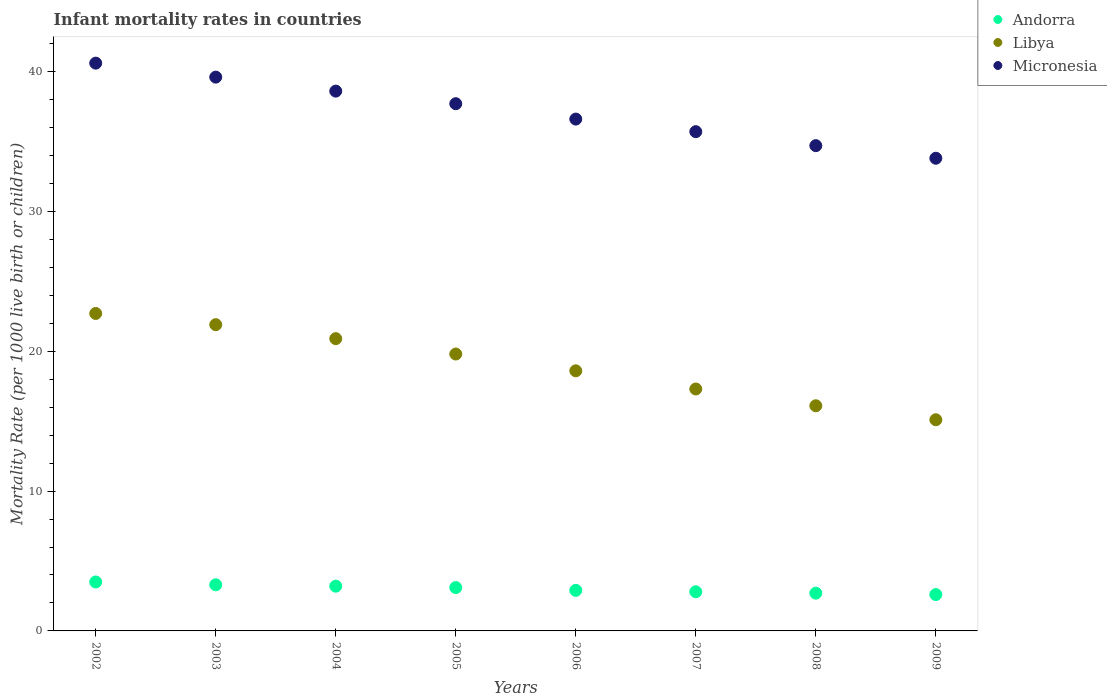How many different coloured dotlines are there?
Provide a succinct answer. 3. Is the number of dotlines equal to the number of legend labels?
Your answer should be compact. Yes. Across all years, what is the maximum infant mortality rate in Libya?
Provide a succinct answer. 22.7. Across all years, what is the minimum infant mortality rate in Andorra?
Make the answer very short. 2.6. In which year was the infant mortality rate in Libya minimum?
Give a very brief answer. 2009. What is the total infant mortality rate in Micronesia in the graph?
Your response must be concise. 297.3. What is the difference between the infant mortality rate in Andorra in 2002 and that in 2008?
Ensure brevity in your answer.  0.8. What is the difference between the infant mortality rate in Micronesia in 2005 and the infant mortality rate in Andorra in 2007?
Your response must be concise. 34.9. What is the average infant mortality rate in Andorra per year?
Your response must be concise. 3.01. In the year 2009, what is the difference between the infant mortality rate in Andorra and infant mortality rate in Micronesia?
Your response must be concise. -31.2. In how many years, is the infant mortality rate in Andorra greater than 24?
Provide a short and direct response. 0. What is the ratio of the infant mortality rate in Micronesia in 2005 to that in 2006?
Provide a short and direct response. 1.03. Is the infant mortality rate in Micronesia in 2003 less than that in 2008?
Your answer should be compact. No. Is the difference between the infant mortality rate in Andorra in 2004 and 2006 greater than the difference between the infant mortality rate in Micronesia in 2004 and 2006?
Keep it short and to the point. No. What is the difference between the highest and the second highest infant mortality rate in Andorra?
Your response must be concise. 0.2. What is the difference between the highest and the lowest infant mortality rate in Libya?
Give a very brief answer. 7.6. Is the sum of the infant mortality rate in Micronesia in 2002 and 2007 greater than the maximum infant mortality rate in Andorra across all years?
Provide a succinct answer. Yes. Is the infant mortality rate in Andorra strictly greater than the infant mortality rate in Libya over the years?
Offer a very short reply. No. Is the infant mortality rate in Libya strictly less than the infant mortality rate in Micronesia over the years?
Give a very brief answer. Yes. What is the difference between two consecutive major ticks on the Y-axis?
Ensure brevity in your answer.  10. Does the graph contain any zero values?
Ensure brevity in your answer.  No. Does the graph contain grids?
Offer a very short reply. No. How are the legend labels stacked?
Keep it short and to the point. Vertical. What is the title of the graph?
Provide a short and direct response. Infant mortality rates in countries. What is the label or title of the Y-axis?
Your answer should be very brief. Mortality Rate (per 1000 live birth or children). What is the Mortality Rate (per 1000 live birth or children) in Andorra in 2002?
Provide a short and direct response. 3.5. What is the Mortality Rate (per 1000 live birth or children) of Libya in 2002?
Your answer should be compact. 22.7. What is the Mortality Rate (per 1000 live birth or children) of Micronesia in 2002?
Keep it short and to the point. 40.6. What is the Mortality Rate (per 1000 live birth or children) in Andorra in 2003?
Provide a succinct answer. 3.3. What is the Mortality Rate (per 1000 live birth or children) in Libya in 2003?
Keep it short and to the point. 21.9. What is the Mortality Rate (per 1000 live birth or children) in Micronesia in 2003?
Give a very brief answer. 39.6. What is the Mortality Rate (per 1000 live birth or children) in Andorra in 2004?
Offer a terse response. 3.2. What is the Mortality Rate (per 1000 live birth or children) in Libya in 2004?
Offer a terse response. 20.9. What is the Mortality Rate (per 1000 live birth or children) of Micronesia in 2004?
Ensure brevity in your answer.  38.6. What is the Mortality Rate (per 1000 live birth or children) in Libya in 2005?
Provide a short and direct response. 19.8. What is the Mortality Rate (per 1000 live birth or children) of Micronesia in 2005?
Provide a short and direct response. 37.7. What is the Mortality Rate (per 1000 live birth or children) in Libya in 2006?
Your response must be concise. 18.6. What is the Mortality Rate (per 1000 live birth or children) of Micronesia in 2006?
Your response must be concise. 36.6. What is the Mortality Rate (per 1000 live birth or children) of Micronesia in 2007?
Provide a short and direct response. 35.7. What is the Mortality Rate (per 1000 live birth or children) in Andorra in 2008?
Provide a succinct answer. 2.7. What is the Mortality Rate (per 1000 live birth or children) of Libya in 2008?
Provide a short and direct response. 16.1. What is the Mortality Rate (per 1000 live birth or children) of Micronesia in 2008?
Your answer should be very brief. 34.7. What is the Mortality Rate (per 1000 live birth or children) in Andorra in 2009?
Provide a succinct answer. 2.6. What is the Mortality Rate (per 1000 live birth or children) in Micronesia in 2009?
Your response must be concise. 33.8. Across all years, what is the maximum Mortality Rate (per 1000 live birth or children) in Andorra?
Ensure brevity in your answer.  3.5. Across all years, what is the maximum Mortality Rate (per 1000 live birth or children) in Libya?
Make the answer very short. 22.7. Across all years, what is the maximum Mortality Rate (per 1000 live birth or children) in Micronesia?
Offer a very short reply. 40.6. Across all years, what is the minimum Mortality Rate (per 1000 live birth or children) in Andorra?
Provide a succinct answer. 2.6. Across all years, what is the minimum Mortality Rate (per 1000 live birth or children) in Micronesia?
Offer a terse response. 33.8. What is the total Mortality Rate (per 1000 live birth or children) of Andorra in the graph?
Offer a terse response. 24.1. What is the total Mortality Rate (per 1000 live birth or children) of Libya in the graph?
Make the answer very short. 152.4. What is the total Mortality Rate (per 1000 live birth or children) in Micronesia in the graph?
Keep it short and to the point. 297.3. What is the difference between the Mortality Rate (per 1000 live birth or children) of Andorra in 2002 and that in 2003?
Make the answer very short. 0.2. What is the difference between the Mortality Rate (per 1000 live birth or children) of Libya in 2002 and that in 2004?
Ensure brevity in your answer.  1.8. What is the difference between the Mortality Rate (per 1000 live birth or children) in Micronesia in 2002 and that in 2004?
Your answer should be compact. 2. What is the difference between the Mortality Rate (per 1000 live birth or children) in Andorra in 2002 and that in 2005?
Offer a terse response. 0.4. What is the difference between the Mortality Rate (per 1000 live birth or children) of Micronesia in 2002 and that in 2005?
Your answer should be very brief. 2.9. What is the difference between the Mortality Rate (per 1000 live birth or children) in Andorra in 2002 and that in 2006?
Make the answer very short. 0.6. What is the difference between the Mortality Rate (per 1000 live birth or children) in Libya in 2002 and that in 2006?
Your answer should be compact. 4.1. What is the difference between the Mortality Rate (per 1000 live birth or children) of Micronesia in 2002 and that in 2006?
Your answer should be compact. 4. What is the difference between the Mortality Rate (per 1000 live birth or children) of Libya in 2002 and that in 2007?
Your answer should be compact. 5.4. What is the difference between the Mortality Rate (per 1000 live birth or children) in Andorra in 2002 and that in 2008?
Your answer should be very brief. 0.8. What is the difference between the Mortality Rate (per 1000 live birth or children) in Andorra in 2002 and that in 2009?
Provide a succinct answer. 0.9. What is the difference between the Mortality Rate (per 1000 live birth or children) in Micronesia in 2002 and that in 2009?
Make the answer very short. 6.8. What is the difference between the Mortality Rate (per 1000 live birth or children) in Andorra in 2003 and that in 2004?
Offer a terse response. 0.1. What is the difference between the Mortality Rate (per 1000 live birth or children) in Andorra in 2003 and that in 2005?
Your answer should be very brief. 0.2. What is the difference between the Mortality Rate (per 1000 live birth or children) in Libya in 2003 and that in 2005?
Ensure brevity in your answer.  2.1. What is the difference between the Mortality Rate (per 1000 live birth or children) in Andorra in 2003 and that in 2006?
Give a very brief answer. 0.4. What is the difference between the Mortality Rate (per 1000 live birth or children) of Libya in 2003 and that in 2006?
Provide a short and direct response. 3.3. What is the difference between the Mortality Rate (per 1000 live birth or children) of Libya in 2003 and that in 2007?
Your answer should be very brief. 4.6. What is the difference between the Mortality Rate (per 1000 live birth or children) of Andorra in 2003 and that in 2008?
Offer a very short reply. 0.6. What is the difference between the Mortality Rate (per 1000 live birth or children) of Andorra in 2003 and that in 2009?
Keep it short and to the point. 0.7. What is the difference between the Mortality Rate (per 1000 live birth or children) of Andorra in 2004 and that in 2005?
Your answer should be very brief. 0.1. What is the difference between the Mortality Rate (per 1000 live birth or children) in Libya in 2004 and that in 2005?
Provide a succinct answer. 1.1. What is the difference between the Mortality Rate (per 1000 live birth or children) of Micronesia in 2004 and that in 2006?
Offer a very short reply. 2. What is the difference between the Mortality Rate (per 1000 live birth or children) of Andorra in 2004 and that in 2007?
Offer a terse response. 0.4. What is the difference between the Mortality Rate (per 1000 live birth or children) of Libya in 2004 and that in 2007?
Provide a succinct answer. 3.6. What is the difference between the Mortality Rate (per 1000 live birth or children) in Libya in 2004 and that in 2008?
Give a very brief answer. 4.8. What is the difference between the Mortality Rate (per 1000 live birth or children) in Andorra in 2004 and that in 2009?
Your answer should be compact. 0.6. What is the difference between the Mortality Rate (per 1000 live birth or children) of Libya in 2004 and that in 2009?
Make the answer very short. 5.8. What is the difference between the Mortality Rate (per 1000 live birth or children) in Libya in 2005 and that in 2006?
Your answer should be very brief. 1.2. What is the difference between the Mortality Rate (per 1000 live birth or children) of Micronesia in 2005 and that in 2006?
Your answer should be very brief. 1.1. What is the difference between the Mortality Rate (per 1000 live birth or children) in Andorra in 2005 and that in 2007?
Provide a short and direct response. 0.3. What is the difference between the Mortality Rate (per 1000 live birth or children) in Micronesia in 2005 and that in 2007?
Your answer should be compact. 2. What is the difference between the Mortality Rate (per 1000 live birth or children) of Andorra in 2005 and that in 2008?
Give a very brief answer. 0.4. What is the difference between the Mortality Rate (per 1000 live birth or children) in Micronesia in 2005 and that in 2008?
Offer a very short reply. 3. What is the difference between the Mortality Rate (per 1000 live birth or children) of Andorra in 2005 and that in 2009?
Provide a succinct answer. 0.5. What is the difference between the Mortality Rate (per 1000 live birth or children) in Libya in 2005 and that in 2009?
Offer a terse response. 4.7. What is the difference between the Mortality Rate (per 1000 live birth or children) in Andorra in 2006 and that in 2007?
Your answer should be compact. 0.1. What is the difference between the Mortality Rate (per 1000 live birth or children) of Andorra in 2006 and that in 2008?
Provide a short and direct response. 0.2. What is the difference between the Mortality Rate (per 1000 live birth or children) in Andorra in 2006 and that in 2009?
Your response must be concise. 0.3. What is the difference between the Mortality Rate (per 1000 live birth or children) in Micronesia in 2006 and that in 2009?
Your answer should be compact. 2.8. What is the difference between the Mortality Rate (per 1000 live birth or children) of Libya in 2007 and that in 2009?
Your answer should be compact. 2.2. What is the difference between the Mortality Rate (per 1000 live birth or children) of Micronesia in 2007 and that in 2009?
Make the answer very short. 1.9. What is the difference between the Mortality Rate (per 1000 live birth or children) in Andorra in 2008 and that in 2009?
Your answer should be compact. 0.1. What is the difference between the Mortality Rate (per 1000 live birth or children) in Libya in 2008 and that in 2009?
Your answer should be compact. 1. What is the difference between the Mortality Rate (per 1000 live birth or children) of Andorra in 2002 and the Mortality Rate (per 1000 live birth or children) of Libya in 2003?
Provide a succinct answer. -18.4. What is the difference between the Mortality Rate (per 1000 live birth or children) of Andorra in 2002 and the Mortality Rate (per 1000 live birth or children) of Micronesia in 2003?
Offer a terse response. -36.1. What is the difference between the Mortality Rate (per 1000 live birth or children) in Libya in 2002 and the Mortality Rate (per 1000 live birth or children) in Micronesia in 2003?
Provide a short and direct response. -16.9. What is the difference between the Mortality Rate (per 1000 live birth or children) in Andorra in 2002 and the Mortality Rate (per 1000 live birth or children) in Libya in 2004?
Offer a very short reply. -17.4. What is the difference between the Mortality Rate (per 1000 live birth or children) in Andorra in 2002 and the Mortality Rate (per 1000 live birth or children) in Micronesia in 2004?
Provide a short and direct response. -35.1. What is the difference between the Mortality Rate (per 1000 live birth or children) in Libya in 2002 and the Mortality Rate (per 1000 live birth or children) in Micronesia in 2004?
Make the answer very short. -15.9. What is the difference between the Mortality Rate (per 1000 live birth or children) in Andorra in 2002 and the Mortality Rate (per 1000 live birth or children) in Libya in 2005?
Your response must be concise. -16.3. What is the difference between the Mortality Rate (per 1000 live birth or children) in Andorra in 2002 and the Mortality Rate (per 1000 live birth or children) in Micronesia in 2005?
Make the answer very short. -34.2. What is the difference between the Mortality Rate (per 1000 live birth or children) in Andorra in 2002 and the Mortality Rate (per 1000 live birth or children) in Libya in 2006?
Your response must be concise. -15.1. What is the difference between the Mortality Rate (per 1000 live birth or children) in Andorra in 2002 and the Mortality Rate (per 1000 live birth or children) in Micronesia in 2006?
Offer a terse response. -33.1. What is the difference between the Mortality Rate (per 1000 live birth or children) of Andorra in 2002 and the Mortality Rate (per 1000 live birth or children) of Libya in 2007?
Provide a succinct answer. -13.8. What is the difference between the Mortality Rate (per 1000 live birth or children) in Andorra in 2002 and the Mortality Rate (per 1000 live birth or children) in Micronesia in 2007?
Ensure brevity in your answer.  -32.2. What is the difference between the Mortality Rate (per 1000 live birth or children) of Andorra in 2002 and the Mortality Rate (per 1000 live birth or children) of Micronesia in 2008?
Offer a terse response. -31.2. What is the difference between the Mortality Rate (per 1000 live birth or children) in Libya in 2002 and the Mortality Rate (per 1000 live birth or children) in Micronesia in 2008?
Your response must be concise. -12. What is the difference between the Mortality Rate (per 1000 live birth or children) of Andorra in 2002 and the Mortality Rate (per 1000 live birth or children) of Libya in 2009?
Give a very brief answer. -11.6. What is the difference between the Mortality Rate (per 1000 live birth or children) in Andorra in 2002 and the Mortality Rate (per 1000 live birth or children) in Micronesia in 2009?
Offer a very short reply. -30.3. What is the difference between the Mortality Rate (per 1000 live birth or children) in Libya in 2002 and the Mortality Rate (per 1000 live birth or children) in Micronesia in 2009?
Provide a short and direct response. -11.1. What is the difference between the Mortality Rate (per 1000 live birth or children) in Andorra in 2003 and the Mortality Rate (per 1000 live birth or children) in Libya in 2004?
Provide a short and direct response. -17.6. What is the difference between the Mortality Rate (per 1000 live birth or children) of Andorra in 2003 and the Mortality Rate (per 1000 live birth or children) of Micronesia in 2004?
Provide a succinct answer. -35.3. What is the difference between the Mortality Rate (per 1000 live birth or children) of Libya in 2003 and the Mortality Rate (per 1000 live birth or children) of Micronesia in 2004?
Give a very brief answer. -16.7. What is the difference between the Mortality Rate (per 1000 live birth or children) of Andorra in 2003 and the Mortality Rate (per 1000 live birth or children) of Libya in 2005?
Your answer should be very brief. -16.5. What is the difference between the Mortality Rate (per 1000 live birth or children) in Andorra in 2003 and the Mortality Rate (per 1000 live birth or children) in Micronesia in 2005?
Keep it short and to the point. -34.4. What is the difference between the Mortality Rate (per 1000 live birth or children) of Libya in 2003 and the Mortality Rate (per 1000 live birth or children) of Micronesia in 2005?
Your answer should be compact. -15.8. What is the difference between the Mortality Rate (per 1000 live birth or children) of Andorra in 2003 and the Mortality Rate (per 1000 live birth or children) of Libya in 2006?
Give a very brief answer. -15.3. What is the difference between the Mortality Rate (per 1000 live birth or children) of Andorra in 2003 and the Mortality Rate (per 1000 live birth or children) of Micronesia in 2006?
Your response must be concise. -33.3. What is the difference between the Mortality Rate (per 1000 live birth or children) in Libya in 2003 and the Mortality Rate (per 1000 live birth or children) in Micronesia in 2006?
Provide a short and direct response. -14.7. What is the difference between the Mortality Rate (per 1000 live birth or children) of Andorra in 2003 and the Mortality Rate (per 1000 live birth or children) of Micronesia in 2007?
Give a very brief answer. -32.4. What is the difference between the Mortality Rate (per 1000 live birth or children) of Andorra in 2003 and the Mortality Rate (per 1000 live birth or children) of Libya in 2008?
Your response must be concise. -12.8. What is the difference between the Mortality Rate (per 1000 live birth or children) of Andorra in 2003 and the Mortality Rate (per 1000 live birth or children) of Micronesia in 2008?
Keep it short and to the point. -31.4. What is the difference between the Mortality Rate (per 1000 live birth or children) in Andorra in 2003 and the Mortality Rate (per 1000 live birth or children) in Libya in 2009?
Your answer should be compact. -11.8. What is the difference between the Mortality Rate (per 1000 live birth or children) of Andorra in 2003 and the Mortality Rate (per 1000 live birth or children) of Micronesia in 2009?
Offer a terse response. -30.5. What is the difference between the Mortality Rate (per 1000 live birth or children) in Andorra in 2004 and the Mortality Rate (per 1000 live birth or children) in Libya in 2005?
Give a very brief answer. -16.6. What is the difference between the Mortality Rate (per 1000 live birth or children) of Andorra in 2004 and the Mortality Rate (per 1000 live birth or children) of Micronesia in 2005?
Your answer should be very brief. -34.5. What is the difference between the Mortality Rate (per 1000 live birth or children) in Libya in 2004 and the Mortality Rate (per 1000 live birth or children) in Micronesia in 2005?
Make the answer very short. -16.8. What is the difference between the Mortality Rate (per 1000 live birth or children) of Andorra in 2004 and the Mortality Rate (per 1000 live birth or children) of Libya in 2006?
Provide a short and direct response. -15.4. What is the difference between the Mortality Rate (per 1000 live birth or children) of Andorra in 2004 and the Mortality Rate (per 1000 live birth or children) of Micronesia in 2006?
Ensure brevity in your answer.  -33.4. What is the difference between the Mortality Rate (per 1000 live birth or children) of Libya in 2004 and the Mortality Rate (per 1000 live birth or children) of Micronesia in 2006?
Provide a succinct answer. -15.7. What is the difference between the Mortality Rate (per 1000 live birth or children) in Andorra in 2004 and the Mortality Rate (per 1000 live birth or children) in Libya in 2007?
Your response must be concise. -14.1. What is the difference between the Mortality Rate (per 1000 live birth or children) in Andorra in 2004 and the Mortality Rate (per 1000 live birth or children) in Micronesia in 2007?
Provide a succinct answer. -32.5. What is the difference between the Mortality Rate (per 1000 live birth or children) in Libya in 2004 and the Mortality Rate (per 1000 live birth or children) in Micronesia in 2007?
Your response must be concise. -14.8. What is the difference between the Mortality Rate (per 1000 live birth or children) of Andorra in 2004 and the Mortality Rate (per 1000 live birth or children) of Micronesia in 2008?
Keep it short and to the point. -31.5. What is the difference between the Mortality Rate (per 1000 live birth or children) of Andorra in 2004 and the Mortality Rate (per 1000 live birth or children) of Micronesia in 2009?
Your answer should be very brief. -30.6. What is the difference between the Mortality Rate (per 1000 live birth or children) in Andorra in 2005 and the Mortality Rate (per 1000 live birth or children) in Libya in 2006?
Your answer should be very brief. -15.5. What is the difference between the Mortality Rate (per 1000 live birth or children) of Andorra in 2005 and the Mortality Rate (per 1000 live birth or children) of Micronesia in 2006?
Make the answer very short. -33.5. What is the difference between the Mortality Rate (per 1000 live birth or children) of Libya in 2005 and the Mortality Rate (per 1000 live birth or children) of Micronesia in 2006?
Offer a very short reply. -16.8. What is the difference between the Mortality Rate (per 1000 live birth or children) of Andorra in 2005 and the Mortality Rate (per 1000 live birth or children) of Micronesia in 2007?
Provide a short and direct response. -32.6. What is the difference between the Mortality Rate (per 1000 live birth or children) in Libya in 2005 and the Mortality Rate (per 1000 live birth or children) in Micronesia in 2007?
Offer a terse response. -15.9. What is the difference between the Mortality Rate (per 1000 live birth or children) of Andorra in 2005 and the Mortality Rate (per 1000 live birth or children) of Micronesia in 2008?
Give a very brief answer. -31.6. What is the difference between the Mortality Rate (per 1000 live birth or children) in Libya in 2005 and the Mortality Rate (per 1000 live birth or children) in Micronesia in 2008?
Make the answer very short. -14.9. What is the difference between the Mortality Rate (per 1000 live birth or children) in Andorra in 2005 and the Mortality Rate (per 1000 live birth or children) in Libya in 2009?
Provide a succinct answer. -12. What is the difference between the Mortality Rate (per 1000 live birth or children) in Andorra in 2005 and the Mortality Rate (per 1000 live birth or children) in Micronesia in 2009?
Provide a succinct answer. -30.7. What is the difference between the Mortality Rate (per 1000 live birth or children) in Andorra in 2006 and the Mortality Rate (per 1000 live birth or children) in Libya in 2007?
Provide a short and direct response. -14.4. What is the difference between the Mortality Rate (per 1000 live birth or children) in Andorra in 2006 and the Mortality Rate (per 1000 live birth or children) in Micronesia in 2007?
Your answer should be compact. -32.8. What is the difference between the Mortality Rate (per 1000 live birth or children) of Libya in 2006 and the Mortality Rate (per 1000 live birth or children) of Micronesia in 2007?
Make the answer very short. -17.1. What is the difference between the Mortality Rate (per 1000 live birth or children) of Andorra in 2006 and the Mortality Rate (per 1000 live birth or children) of Micronesia in 2008?
Your answer should be compact. -31.8. What is the difference between the Mortality Rate (per 1000 live birth or children) of Libya in 2006 and the Mortality Rate (per 1000 live birth or children) of Micronesia in 2008?
Keep it short and to the point. -16.1. What is the difference between the Mortality Rate (per 1000 live birth or children) in Andorra in 2006 and the Mortality Rate (per 1000 live birth or children) in Micronesia in 2009?
Offer a terse response. -30.9. What is the difference between the Mortality Rate (per 1000 live birth or children) in Libya in 2006 and the Mortality Rate (per 1000 live birth or children) in Micronesia in 2009?
Provide a short and direct response. -15.2. What is the difference between the Mortality Rate (per 1000 live birth or children) in Andorra in 2007 and the Mortality Rate (per 1000 live birth or children) in Libya in 2008?
Offer a terse response. -13.3. What is the difference between the Mortality Rate (per 1000 live birth or children) of Andorra in 2007 and the Mortality Rate (per 1000 live birth or children) of Micronesia in 2008?
Ensure brevity in your answer.  -31.9. What is the difference between the Mortality Rate (per 1000 live birth or children) in Libya in 2007 and the Mortality Rate (per 1000 live birth or children) in Micronesia in 2008?
Your answer should be very brief. -17.4. What is the difference between the Mortality Rate (per 1000 live birth or children) in Andorra in 2007 and the Mortality Rate (per 1000 live birth or children) in Libya in 2009?
Provide a short and direct response. -12.3. What is the difference between the Mortality Rate (per 1000 live birth or children) of Andorra in 2007 and the Mortality Rate (per 1000 live birth or children) of Micronesia in 2009?
Offer a very short reply. -31. What is the difference between the Mortality Rate (per 1000 live birth or children) in Libya in 2007 and the Mortality Rate (per 1000 live birth or children) in Micronesia in 2009?
Ensure brevity in your answer.  -16.5. What is the difference between the Mortality Rate (per 1000 live birth or children) in Andorra in 2008 and the Mortality Rate (per 1000 live birth or children) in Micronesia in 2009?
Make the answer very short. -31.1. What is the difference between the Mortality Rate (per 1000 live birth or children) of Libya in 2008 and the Mortality Rate (per 1000 live birth or children) of Micronesia in 2009?
Make the answer very short. -17.7. What is the average Mortality Rate (per 1000 live birth or children) of Andorra per year?
Offer a terse response. 3.01. What is the average Mortality Rate (per 1000 live birth or children) in Libya per year?
Offer a terse response. 19.05. What is the average Mortality Rate (per 1000 live birth or children) in Micronesia per year?
Your answer should be compact. 37.16. In the year 2002, what is the difference between the Mortality Rate (per 1000 live birth or children) in Andorra and Mortality Rate (per 1000 live birth or children) in Libya?
Provide a short and direct response. -19.2. In the year 2002, what is the difference between the Mortality Rate (per 1000 live birth or children) in Andorra and Mortality Rate (per 1000 live birth or children) in Micronesia?
Make the answer very short. -37.1. In the year 2002, what is the difference between the Mortality Rate (per 1000 live birth or children) in Libya and Mortality Rate (per 1000 live birth or children) in Micronesia?
Your answer should be very brief. -17.9. In the year 2003, what is the difference between the Mortality Rate (per 1000 live birth or children) of Andorra and Mortality Rate (per 1000 live birth or children) of Libya?
Offer a terse response. -18.6. In the year 2003, what is the difference between the Mortality Rate (per 1000 live birth or children) in Andorra and Mortality Rate (per 1000 live birth or children) in Micronesia?
Offer a terse response. -36.3. In the year 2003, what is the difference between the Mortality Rate (per 1000 live birth or children) in Libya and Mortality Rate (per 1000 live birth or children) in Micronesia?
Offer a terse response. -17.7. In the year 2004, what is the difference between the Mortality Rate (per 1000 live birth or children) of Andorra and Mortality Rate (per 1000 live birth or children) of Libya?
Offer a terse response. -17.7. In the year 2004, what is the difference between the Mortality Rate (per 1000 live birth or children) in Andorra and Mortality Rate (per 1000 live birth or children) in Micronesia?
Provide a short and direct response. -35.4. In the year 2004, what is the difference between the Mortality Rate (per 1000 live birth or children) in Libya and Mortality Rate (per 1000 live birth or children) in Micronesia?
Your response must be concise. -17.7. In the year 2005, what is the difference between the Mortality Rate (per 1000 live birth or children) of Andorra and Mortality Rate (per 1000 live birth or children) of Libya?
Your answer should be compact. -16.7. In the year 2005, what is the difference between the Mortality Rate (per 1000 live birth or children) in Andorra and Mortality Rate (per 1000 live birth or children) in Micronesia?
Provide a succinct answer. -34.6. In the year 2005, what is the difference between the Mortality Rate (per 1000 live birth or children) of Libya and Mortality Rate (per 1000 live birth or children) of Micronesia?
Provide a succinct answer. -17.9. In the year 2006, what is the difference between the Mortality Rate (per 1000 live birth or children) of Andorra and Mortality Rate (per 1000 live birth or children) of Libya?
Offer a terse response. -15.7. In the year 2006, what is the difference between the Mortality Rate (per 1000 live birth or children) of Andorra and Mortality Rate (per 1000 live birth or children) of Micronesia?
Give a very brief answer. -33.7. In the year 2007, what is the difference between the Mortality Rate (per 1000 live birth or children) of Andorra and Mortality Rate (per 1000 live birth or children) of Libya?
Give a very brief answer. -14.5. In the year 2007, what is the difference between the Mortality Rate (per 1000 live birth or children) in Andorra and Mortality Rate (per 1000 live birth or children) in Micronesia?
Offer a very short reply. -32.9. In the year 2007, what is the difference between the Mortality Rate (per 1000 live birth or children) in Libya and Mortality Rate (per 1000 live birth or children) in Micronesia?
Give a very brief answer. -18.4. In the year 2008, what is the difference between the Mortality Rate (per 1000 live birth or children) of Andorra and Mortality Rate (per 1000 live birth or children) of Libya?
Offer a terse response. -13.4. In the year 2008, what is the difference between the Mortality Rate (per 1000 live birth or children) in Andorra and Mortality Rate (per 1000 live birth or children) in Micronesia?
Your answer should be compact. -32. In the year 2008, what is the difference between the Mortality Rate (per 1000 live birth or children) in Libya and Mortality Rate (per 1000 live birth or children) in Micronesia?
Provide a short and direct response. -18.6. In the year 2009, what is the difference between the Mortality Rate (per 1000 live birth or children) in Andorra and Mortality Rate (per 1000 live birth or children) in Micronesia?
Provide a short and direct response. -31.2. In the year 2009, what is the difference between the Mortality Rate (per 1000 live birth or children) of Libya and Mortality Rate (per 1000 live birth or children) of Micronesia?
Your answer should be very brief. -18.7. What is the ratio of the Mortality Rate (per 1000 live birth or children) in Andorra in 2002 to that in 2003?
Provide a short and direct response. 1.06. What is the ratio of the Mortality Rate (per 1000 live birth or children) in Libya in 2002 to that in 2003?
Provide a succinct answer. 1.04. What is the ratio of the Mortality Rate (per 1000 live birth or children) of Micronesia in 2002 to that in 2003?
Ensure brevity in your answer.  1.03. What is the ratio of the Mortality Rate (per 1000 live birth or children) in Andorra in 2002 to that in 2004?
Give a very brief answer. 1.09. What is the ratio of the Mortality Rate (per 1000 live birth or children) of Libya in 2002 to that in 2004?
Keep it short and to the point. 1.09. What is the ratio of the Mortality Rate (per 1000 live birth or children) in Micronesia in 2002 to that in 2004?
Keep it short and to the point. 1.05. What is the ratio of the Mortality Rate (per 1000 live birth or children) of Andorra in 2002 to that in 2005?
Your answer should be very brief. 1.13. What is the ratio of the Mortality Rate (per 1000 live birth or children) in Libya in 2002 to that in 2005?
Give a very brief answer. 1.15. What is the ratio of the Mortality Rate (per 1000 live birth or children) in Micronesia in 2002 to that in 2005?
Keep it short and to the point. 1.08. What is the ratio of the Mortality Rate (per 1000 live birth or children) of Andorra in 2002 to that in 2006?
Offer a very short reply. 1.21. What is the ratio of the Mortality Rate (per 1000 live birth or children) in Libya in 2002 to that in 2006?
Provide a short and direct response. 1.22. What is the ratio of the Mortality Rate (per 1000 live birth or children) of Micronesia in 2002 to that in 2006?
Your answer should be very brief. 1.11. What is the ratio of the Mortality Rate (per 1000 live birth or children) of Andorra in 2002 to that in 2007?
Your answer should be very brief. 1.25. What is the ratio of the Mortality Rate (per 1000 live birth or children) of Libya in 2002 to that in 2007?
Your answer should be compact. 1.31. What is the ratio of the Mortality Rate (per 1000 live birth or children) in Micronesia in 2002 to that in 2007?
Give a very brief answer. 1.14. What is the ratio of the Mortality Rate (per 1000 live birth or children) of Andorra in 2002 to that in 2008?
Your answer should be very brief. 1.3. What is the ratio of the Mortality Rate (per 1000 live birth or children) in Libya in 2002 to that in 2008?
Provide a short and direct response. 1.41. What is the ratio of the Mortality Rate (per 1000 live birth or children) in Micronesia in 2002 to that in 2008?
Ensure brevity in your answer.  1.17. What is the ratio of the Mortality Rate (per 1000 live birth or children) of Andorra in 2002 to that in 2009?
Make the answer very short. 1.35. What is the ratio of the Mortality Rate (per 1000 live birth or children) in Libya in 2002 to that in 2009?
Give a very brief answer. 1.5. What is the ratio of the Mortality Rate (per 1000 live birth or children) in Micronesia in 2002 to that in 2009?
Make the answer very short. 1.2. What is the ratio of the Mortality Rate (per 1000 live birth or children) of Andorra in 2003 to that in 2004?
Offer a terse response. 1.03. What is the ratio of the Mortality Rate (per 1000 live birth or children) in Libya in 2003 to that in 2004?
Your answer should be very brief. 1.05. What is the ratio of the Mortality Rate (per 1000 live birth or children) of Micronesia in 2003 to that in 2004?
Give a very brief answer. 1.03. What is the ratio of the Mortality Rate (per 1000 live birth or children) in Andorra in 2003 to that in 2005?
Your answer should be compact. 1.06. What is the ratio of the Mortality Rate (per 1000 live birth or children) of Libya in 2003 to that in 2005?
Make the answer very short. 1.11. What is the ratio of the Mortality Rate (per 1000 live birth or children) of Micronesia in 2003 to that in 2005?
Your response must be concise. 1.05. What is the ratio of the Mortality Rate (per 1000 live birth or children) in Andorra in 2003 to that in 2006?
Provide a succinct answer. 1.14. What is the ratio of the Mortality Rate (per 1000 live birth or children) in Libya in 2003 to that in 2006?
Your answer should be very brief. 1.18. What is the ratio of the Mortality Rate (per 1000 live birth or children) of Micronesia in 2003 to that in 2006?
Your response must be concise. 1.08. What is the ratio of the Mortality Rate (per 1000 live birth or children) of Andorra in 2003 to that in 2007?
Your answer should be very brief. 1.18. What is the ratio of the Mortality Rate (per 1000 live birth or children) in Libya in 2003 to that in 2007?
Your answer should be very brief. 1.27. What is the ratio of the Mortality Rate (per 1000 live birth or children) in Micronesia in 2003 to that in 2007?
Your response must be concise. 1.11. What is the ratio of the Mortality Rate (per 1000 live birth or children) in Andorra in 2003 to that in 2008?
Your answer should be very brief. 1.22. What is the ratio of the Mortality Rate (per 1000 live birth or children) in Libya in 2003 to that in 2008?
Keep it short and to the point. 1.36. What is the ratio of the Mortality Rate (per 1000 live birth or children) of Micronesia in 2003 to that in 2008?
Provide a succinct answer. 1.14. What is the ratio of the Mortality Rate (per 1000 live birth or children) of Andorra in 2003 to that in 2009?
Your answer should be compact. 1.27. What is the ratio of the Mortality Rate (per 1000 live birth or children) of Libya in 2003 to that in 2009?
Your answer should be compact. 1.45. What is the ratio of the Mortality Rate (per 1000 live birth or children) in Micronesia in 2003 to that in 2009?
Provide a short and direct response. 1.17. What is the ratio of the Mortality Rate (per 1000 live birth or children) in Andorra in 2004 to that in 2005?
Offer a very short reply. 1.03. What is the ratio of the Mortality Rate (per 1000 live birth or children) of Libya in 2004 to that in 2005?
Give a very brief answer. 1.06. What is the ratio of the Mortality Rate (per 1000 live birth or children) of Micronesia in 2004 to that in 2005?
Provide a short and direct response. 1.02. What is the ratio of the Mortality Rate (per 1000 live birth or children) in Andorra in 2004 to that in 2006?
Your answer should be very brief. 1.1. What is the ratio of the Mortality Rate (per 1000 live birth or children) in Libya in 2004 to that in 2006?
Offer a terse response. 1.12. What is the ratio of the Mortality Rate (per 1000 live birth or children) in Micronesia in 2004 to that in 2006?
Your answer should be compact. 1.05. What is the ratio of the Mortality Rate (per 1000 live birth or children) in Libya in 2004 to that in 2007?
Give a very brief answer. 1.21. What is the ratio of the Mortality Rate (per 1000 live birth or children) in Micronesia in 2004 to that in 2007?
Your answer should be very brief. 1.08. What is the ratio of the Mortality Rate (per 1000 live birth or children) in Andorra in 2004 to that in 2008?
Your answer should be compact. 1.19. What is the ratio of the Mortality Rate (per 1000 live birth or children) of Libya in 2004 to that in 2008?
Offer a very short reply. 1.3. What is the ratio of the Mortality Rate (per 1000 live birth or children) of Micronesia in 2004 to that in 2008?
Keep it short and to the point. 1.11. What is the ratio of the Mortality Rate (per 1000 live birth or children) in Andorra in 2004 to that in 2009?
Give a very brief answer. 1.23. What is the ratio of the Mortality Rate (per 1000 live birth or children) in Libya in 2004 to that in 2009?
Keep it short and to the point. 1.38. What is the ratio of the Mortality Rate (per 1000 live birth or children) in Micronesia in 2004 to that in 2009?
Offer a terse response. 1.14. What is the ratio of the Mortality Rate (per 1000 live birth or children) in Andorra in 2005 to that in 2006?
Provide a succinct answer. 1.07. What is the ratio of the Mortality Rate (per 1000 live birth or children) of Libya in 2005 to that in 2006?
Your response must be concise. 1.06. What is the ratio of the Mortality Rate (per 1000 live birth or children) in Micronesia in 2005 to that in 2006?
Give a very brief answer. 1.03. What is the ratio of the Mortality Rate (per 1000 live birth or children) of Andorra in 2005 to that in 2007?
Ensure brevity in your answer.  1.11. What is the ratio of the Mortality Rate (per 1000 live birth or children) in Libya in 2005 to that in 2007?
Offer a terse response. 1.14. What is the ratio of the Mortality Rate (per 1000 live birth or children) in Micronesia in 2005 to that in 2007?
Your answer should be compact. 1.06. What is the ratio of the Mortality Rate (per 1000 live birth or children) in Andorra in 2005 to that in 2008?
Your response must be concise. 1.15. What is the ratio of the Mortality Rate (per 1000 live birth or children) of Libya in 2005 to that in 2008?
Keep it short and to the point. 1.23. What is the ratio of the Mortality Rate (per 1000 live birth or children) of Micronesia in 2005 to that in 2008?
Offer a very short reply. 1.09. What is the ratio of the Mortality Rate (per 1000 live birth or children) in Andorra in 2005 to that in 2009?
Ensure brevity in your answer.  1.19. What is the ratio of the Mortality Rate (per 1000 live birth or children) of Libya in 2005 to that in 2009?
Offer a very short reply. 1.31. What is the ratio of the Mortality Rate (per 1000 live birth or children) in Micronesia in 2005 to that in 2009?
Provide a succinct answer. 1.12. What is the ratio of the Mortality Rate (per 1000 live birth or children) of Andorra in 2006 to that in 2007?
Provide a succinct answer. 1.04. What is the ratio of the Mortality Rate (per 1000 live birth or children) of Libya in 2006 to that in 2007?
Offer a very short reply. 1.08. What is the ratio of the Mortality Rate (per 1000 live birth or children) of Micronesia in 2006 to that in 2007?
Provide a short and direct response. 1.03. What is the ratio of the Mortality Rate (per 1000 live birth or children) of Andorra in 2006 to that in 2008?
Your answer should be compact. 1.07. What is the ratio of the Mortality Rate (per 1000 live birth or children) in Libya in 2006 to that in 2008?
Your response must be concise. 1.16. What is the ratio of the Mortality Rate (per 1000 live birth or children) of Micronesia in 2006 to that in 2008?
Ensure brevity in your answer.  1.05. What is the ratio of the Mortality Rate (per 1000 live birth or children) of Andorra in 2006 to that in 2009?
Ensure brevity in your answer.  1.12. What is the ratio of the Mortality Rate (per 1000 live birth or children) in Libya in 2006 to that in 2009?
Provide a succinct answer. 1.23. What is the ratio of the Mortality Rate (per 1000 live birth or children) of Micronesia in 2006 to that in 2009?
Your response must be concise. 1.08. What is the ratio of the Mortality Rate (per 1000 live birth or children) of Libya in 2007 to that in 2008?
Offer a very short reply. 1.07. What is the ratio of the Mortality Rate (per 1000 live birth or children) in Micronesia in 2007 to that in 2008?
Provide a succinct answer. 1.03. What is the ratio of the Mortality Rate (per 1000 live birth or children) in Andorra in 2007 to that in 2009?
Your answer should be very brief. 1.08. What is the ratio of the Mortality Rate (per 1000 live birth or children) of Libya in 2007 to that in 2009?
Offer a terse response. 1.15. What is the ratio of the Mortality Rate (per 1000 live birth or children) of Micronesia in 2007 to that in 2009?
Keep it short and to the point. 1.06. What is the ratio of the Mortality Rate (per 1000 live birth or children) in Andorra in 2008 to that in 2009?
Provide a short and direct response. 1.04. What is the ratio of the Mortality Rate (per 1000 live birth or children) in Libya in 2008 to that in 2009?
Ensure brevity in your answer.  1.07. What is the ratio of the Mortality Rate (per 1000 live birth or children) in Micronesia in 2008 to that in 2009?
Offer a terse response. 1.03. What is the difference between the highest and the second highest Mortality Rate (per 1000 live birth or children) in Andorra?
Ensure brevity in your answer.  0.2. What is the difference between the highest and the second highest Mortality Rate (per 1000 live birth or children) in Micronesia?
Your answer should be compact. 1. What is the difference between the highest and the lowest Mortality Rate (per 1000 live birth or children) in Libya?
Provide a short and direct response. 7.6. What is the difference between the highest and the lowest Mortality Rate (per 1000 live birth or children) in Micronesia?
Give a very brief answer. 6.8. 